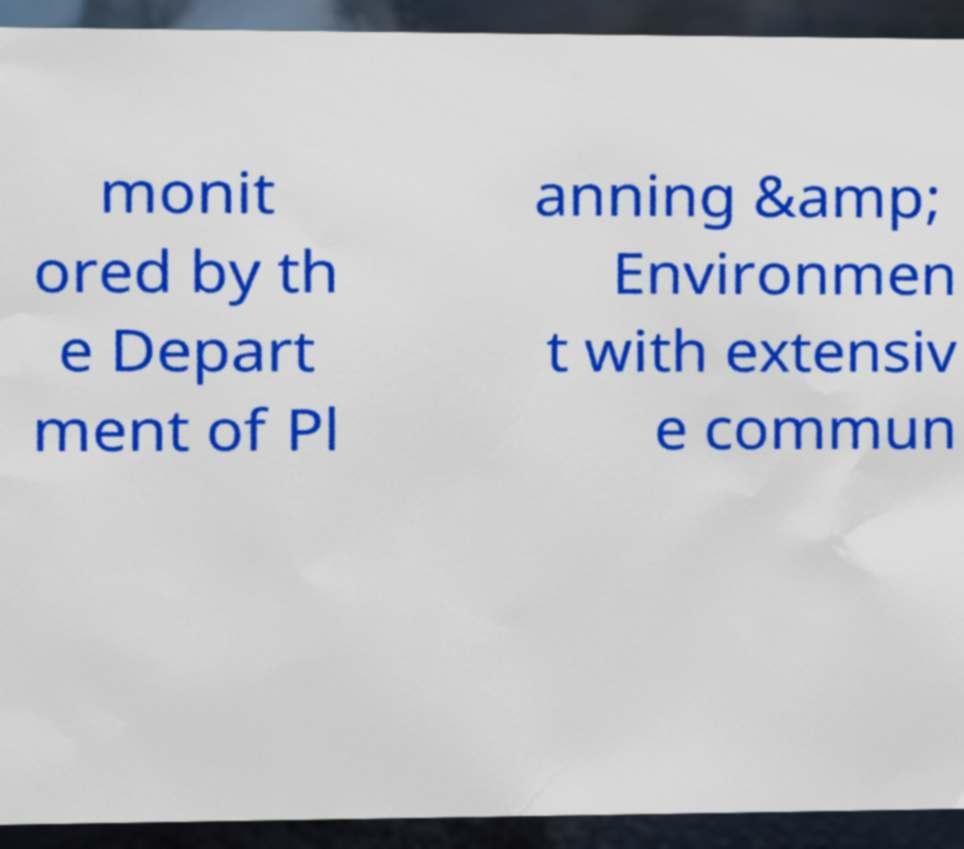There's text embedded in this image that I need extracted. Can you transcribe it verbatim? monit ored by th e Depart ment of Pl anning &amp; Environmen t with extensiv e commun 